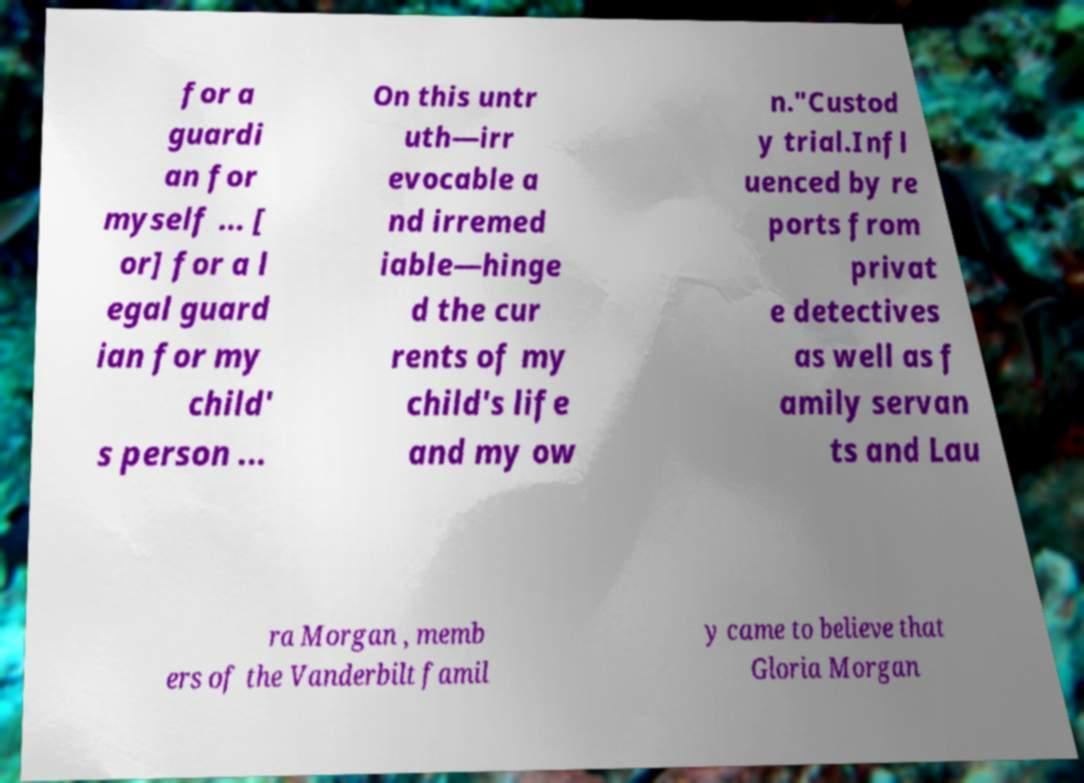Could you extract and type out the text from this image? for a guardi an for myself ... [ or] for a l egal guard ian for my child' s person ... On this untr uth—irr evocable a nd irremed iable—hinge d the cur rents of my child's life and my ow n."Custod y trial.Infl uenced by re ports from privat e detectives as well as f amily servan ts and Lau ra Morgan , memb ers of the Vanderbilt famil y came to believe that Gloria Morgan 